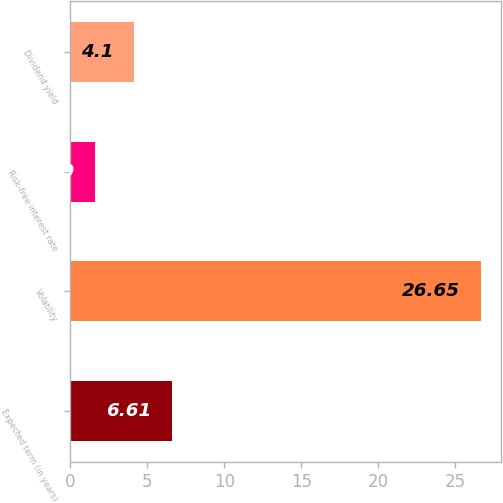Convert chart to OTSL. <chart><loc_0><loc_0><loc_500><loc_500><bar_chart><fcel>Expected term (in years)<fcel>Volatility<fcel>Risk-free interest rate<fcel>Dividend yield<nl><fcel>6.61<fcel>26.65<fcel>1.59<fcel>4.1<nl></chart> 